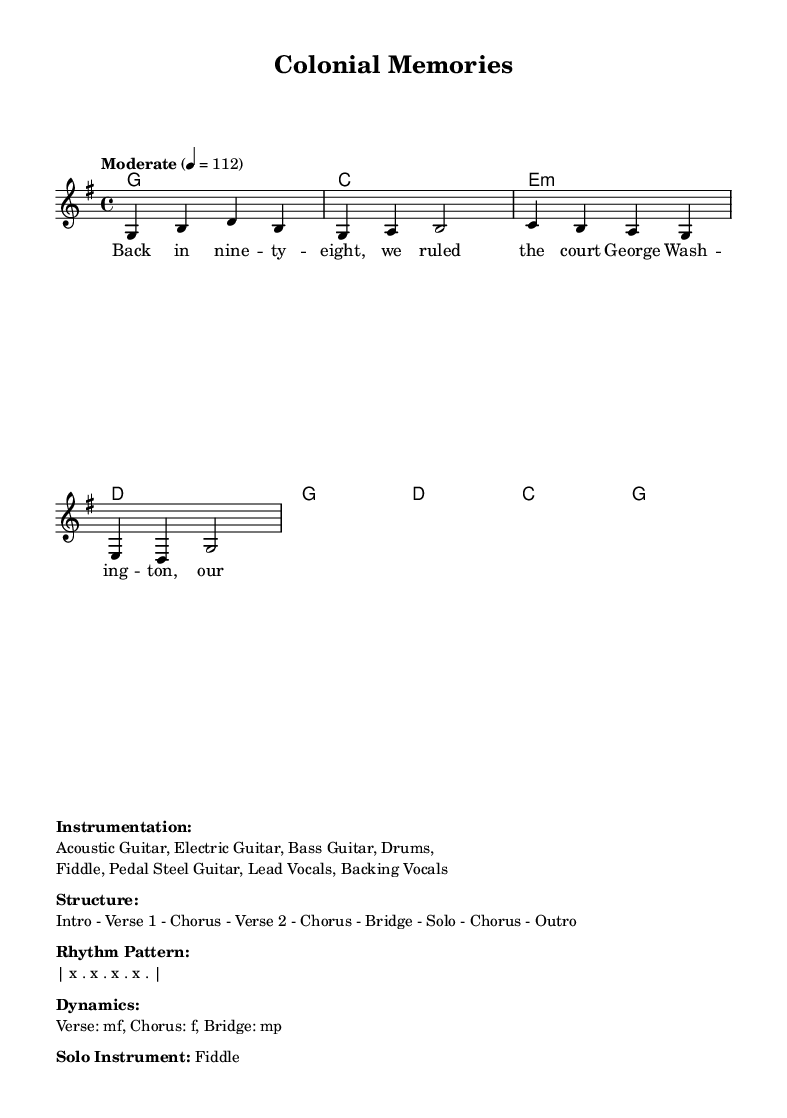What is the key signature of this music? The key signature is G major, which has one sharp (F#). In the sheet music, the key signature is indicated at the beginning, showing a single sharp in the staff line.
Answer: G major What is the time signature of the music? The time signature is 4/4, which means there are four beats in each measure and the quarter note gets one beat. This can be seen at the beginning of the score, written after the key signature.
Answer: 4/4 What is the tempo marking of the piece? The tempo marking indicates a speed of 112 beats per minute. This is specified at the beginning of the score and defines how fast the music should be played.
Answer: 112 How many verses are in the structure of the music? The structure outlined includes two verses. This can be found in the "Structure" section of the markup, which specifies the sequence of sections in the song.
Answer: Two What dynamic marking is indicated for the chorus? The chorus is marked as "f", which means fortissimo, or very loud. This is mentioned in the "Dynamics" section of the markup, giving guidance on how to perform the chorus.
Answer: f What is the solo instrument featured in this piece? The solo instrument indicated is the fiddle. This is explicitly mentioned in the "Solo Instrument" section of the markup, indicating the primary instrument for the solo part of the music.
Answer: Fiddle 